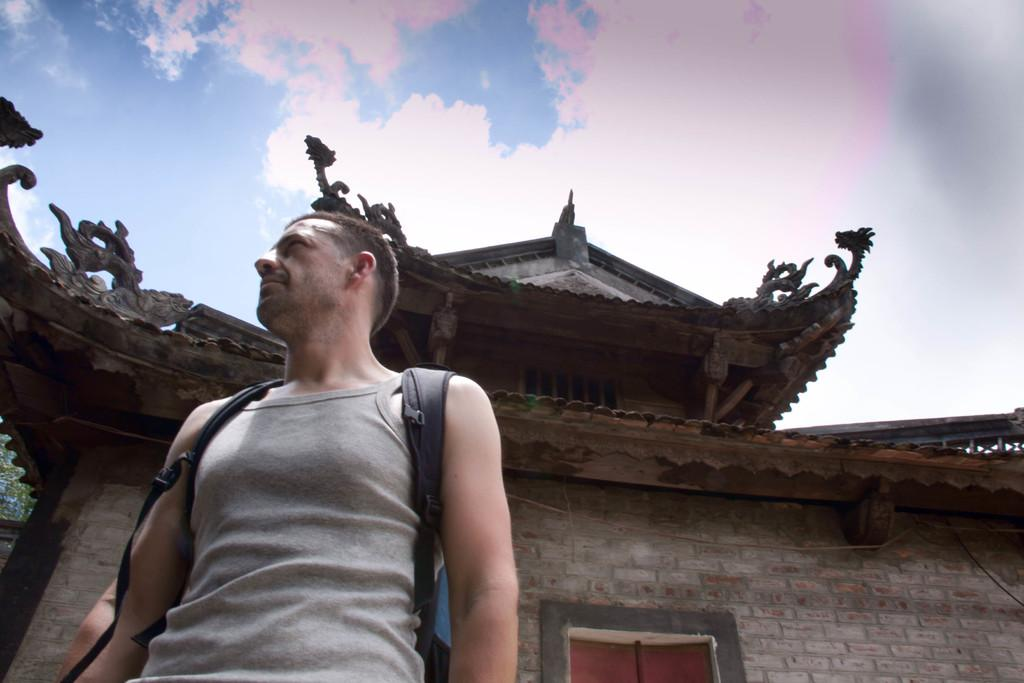What is the main subject of the image? There is a person in the image. What is the person wearing? The person is wearing a bag. In which direction is the person looking? The person is looking to the left side of the image. What can be seen behind the person? There is a building behind the person. What is visible in the background of the image? The sky is visible in the background of the image. What type of snow can be seen on the ground in the image? There is no snow present in the image; it is not mentioned in the provided facts. 